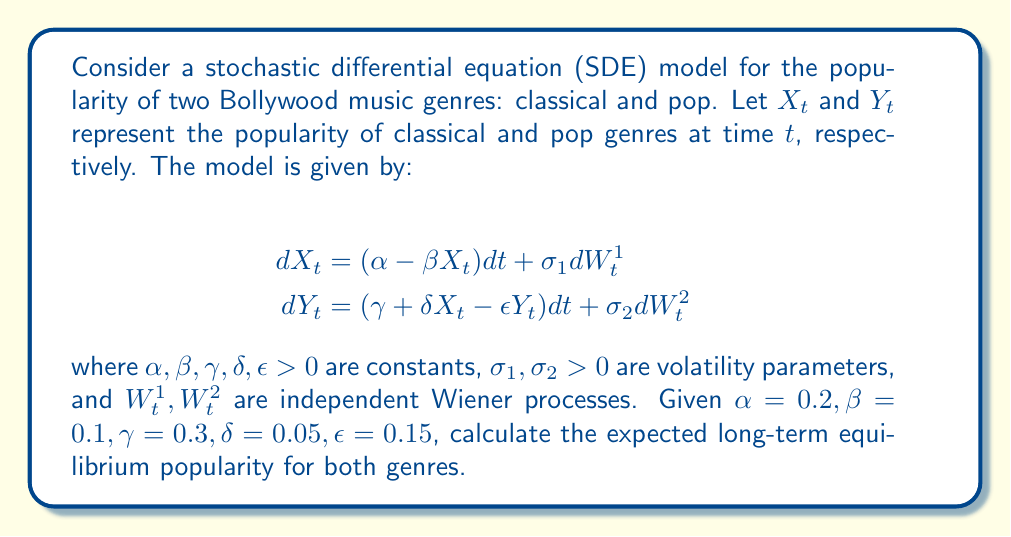Can you answer this question? To find the long-term equilibrium popularity, we need to follow these steps:

1) First, we calculate the expected values of $X_t$ and $Y_t$ by taking the expectation of both sides of the SDEs:

   $$\begin{align}
   d\mathbb{E}[X_t] &= (\alpha - \beta \mathbb{E}[X_t])dt \\
   d\mathbb{E}[Y_t] &= (\gamma + \delta \mathbb{E}[X_t] - \epsilon \mathbb{E}[Y_t])dt
   \end{align}$$

2) In the long-term equilibrium, these expected values should be constant, so their derivatives should be zero:

   $$\begin{align}
   0 &= \alpha - \beta \mathbb{E}[X_\infty] \\
   0 &= \gamma + \delta \mathbb{E}[X_\infty] - \epsilon \mathbb{E}[Y_\infty]
   \end{align}$$

3) From the first equation, we can find $\mathbb{E}[X_\infty]$:

   $$\mathbb{E}[X_\infty] = \frac{\alpha}{\beta} = \frac{0.2}{0.1} = 2$$

4) Substituting this into the second equation:

   $$0 = \gamma + \delta \mathbb{E}[X_\infty] - \epsilon \mathbb{E}[Y_\infty]$$
   $$0 = 0.3 + 0.05(2) - 0.15 \mathbb{E}[Y_\infty]$$
   $$0.15 \mathbb{E}[Y_\infty] = 0.4$$

5) Solving for $\mathbb{E}[Y_\infty]$:

   $$\mathbb{E}[Y_\infty] = \frac{0.4}{0.15} \approx 2.67$$

Therefore, the expected long-term equilibrium popularity for the classical genre is 2, and for the pop genre is approximately 2.67.
Answer: Classical: 2, Pop: 2.67 